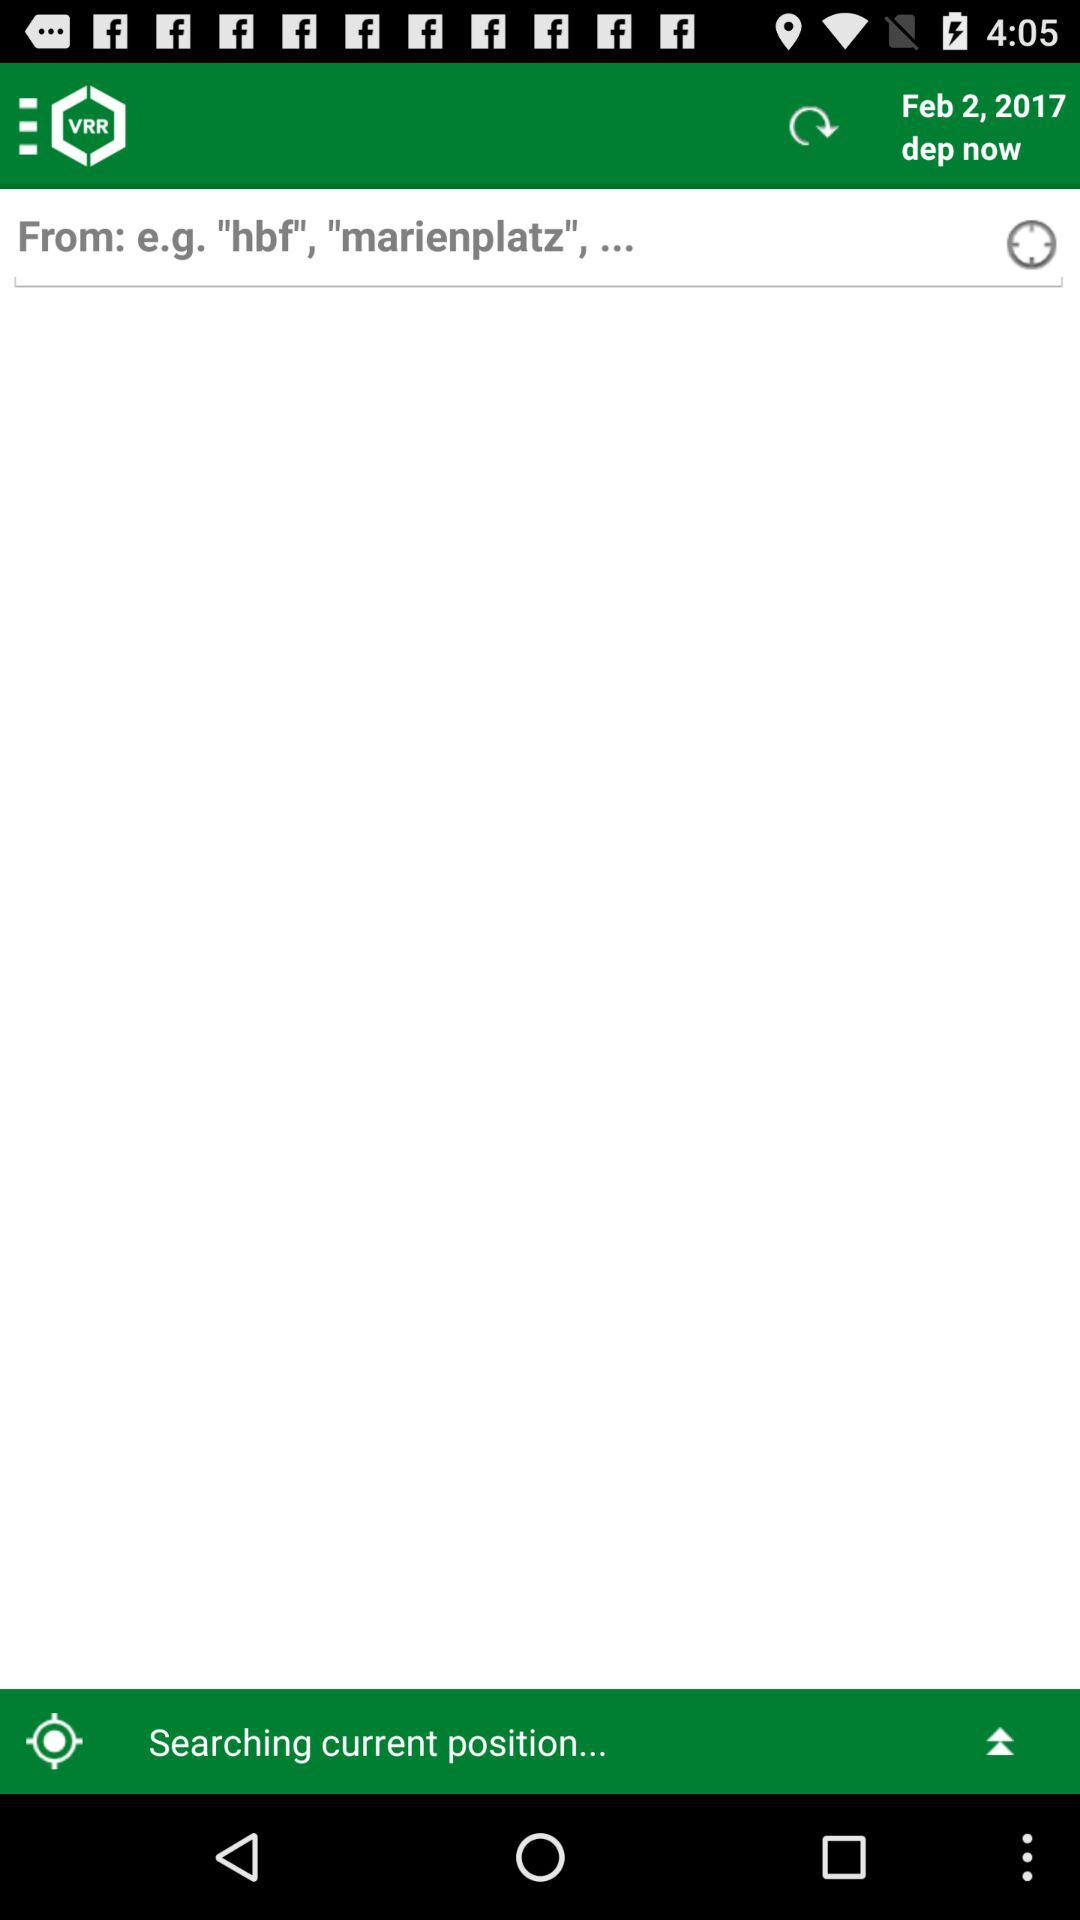What is the application name? The application name is "VRR". 